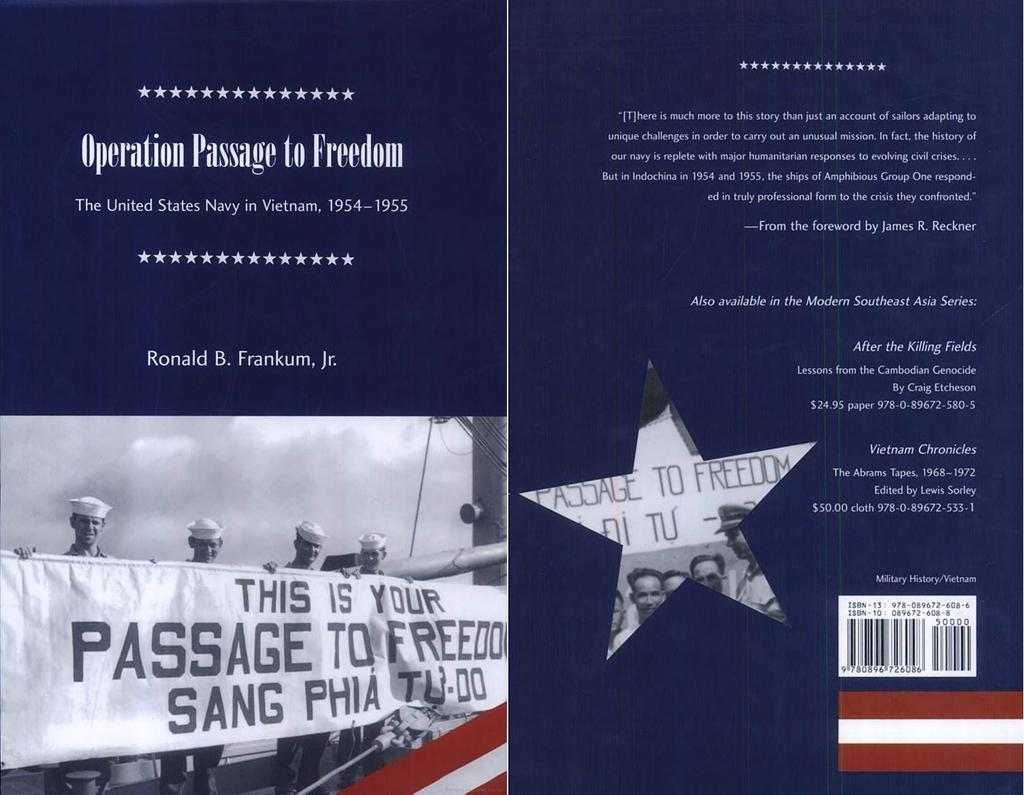Provide a one-sentence caption for the provided image. a pamphlet by the united states navy about viet nam. 